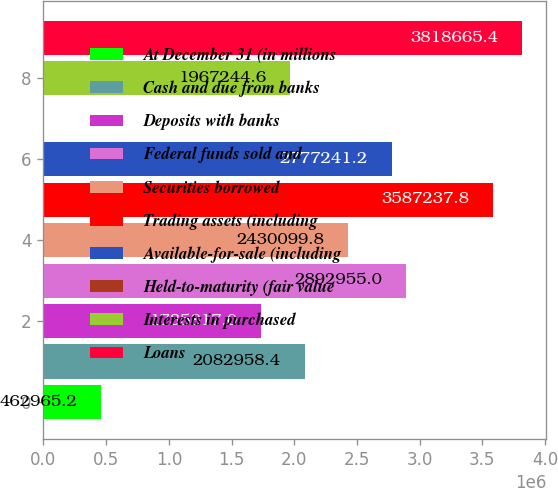Convert chart. <chart><loc_0><loc_0><loc_500><loc_500><bar_chart><fcel>At December 31 (in millions<fcel>Cash and due from banks<fcel>Deposits with banks<fcel>Federal funds sold and<fcel>Securities borrowed<fcel>Trading assets (including<fcel>Available-for-sale (including<fcel>Held-to-maturity (fair value<fcel>Interests in purchased<fcel>Loans<nl><fcel>462965<fcel>2.08296e+06<fcel>1.73582e+06<fcel>2.89296e+06<fcel>2.4301e+06<fcel>3.58724e+06<fcel>2.77724e+06<fcel>110<fcel>1.96724e+06<fcel>3.81867e+06<nl></chart> 